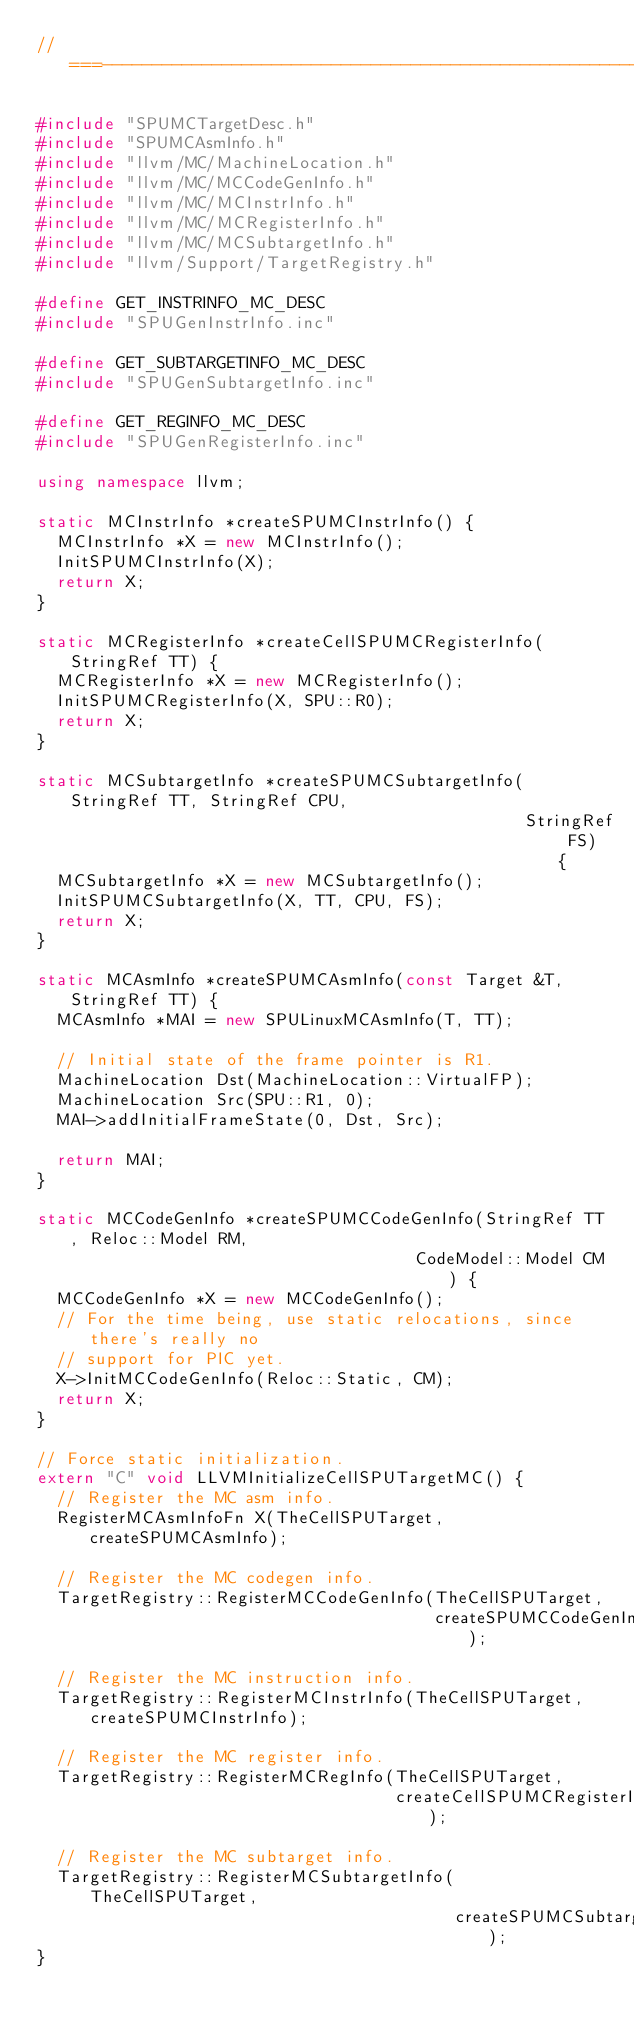<code> <loc_0><loc_0><loc_500><loc_500><_C++_>//===----------------------------------------------------------------------===//

#include "SPUMCTargetDesc.h"
#include "SPUMCAsmInfo.h"
#include "llvm/MC/MachineLocation.h"
#include "llvm/MC/MCCodeGenInfo.h"
#include "llvm/MC/MCInstrInfo.h"
#include "llvm/MC/MCRegisterInfo.h"
#include "llvm/MC/MCSubtargetInfo.h"
#include "llvm/Support/TargetRegistry.h"

#define GET_INSTRINFO_MC_DESC
#include "SPUGenInstrInfo.inc"

#define GET_SUBTARGETINFO_MC_DESC
#include "SPUGenSubtargetInfo.inc"

#define GET_REGINFO_MC_DESC
#include "SPUGenRegisterInfo.inc"

using namespace llvm;

static MCInstrInfo *createSPUMCInstrInfo() {
  MCInstrInfo *X = new MCInstrInfo();
  InitSPUMCInstrInfo(X);
  return X;
}

static MCRegisterInfo *createCellSPUMCRegisterInfo(StringRef TT) {
  MCRegisterInfo *X = new MCRegisterInfo();
  InitSPUMCRegisterInfo(X, SPU::R0);
  return X;
}

static MCSubtargetInfo *createSPUMCSubtargetInfo(StringRef TT, StringRef CPU,
                                                 StringRef FS) {
  MCSubtargetInfo *X = new MCSubtargetInfo();
  InitSPUMCSubtargetInfo(X, TT, CPU, FS);
  return X;
}

static MCAsmInfo *createSPUMCAsmInfo(const Target &T, StringRef TT) {
  MCAsmInfo *MAI = new SPULinuxMCAsmInfo(T, TT);

  // Initial state of the frame pointer is R1.
  MachineLocation Dst(MachineLocation::VirtualFP);
  MachineLocation Src(SPU::R1, 0);
  MAI->addInitialFrameState(0, Dst, Src);

  return MAI;
}

static MCCodeGenInfo *createSPUMCCodeGenInfo(StringRef TT, Reloc::Model RM,
                                      CodeModel::Model CM) {
  MCCodeGenInfo *X = new MCCodeGenInfo();
  // For the time being, use static relocations, since there's really no
  // support for PIC yet.
  X->InitMCCodeGenInfo(Reloc::Static, CM);
  return X;
}

// Force static initialization.
extern "C" void LLVMInitializeCellSPUTargetMC() {
  // Register the MC asm info.
  RegisterMCAsmInfoFn X(TheCellSPUTarget, createSPUMCAsmInfo);

  // Register the MC codegen info.
  TargetRegistry::RegisterMCCodeGenInfo(TheCellSPUTarget,
                                        createSPUMCCodeGenInfo);

  // Register the MC instruction info.
  TargetRegistry::RegisterMCInstrInfo(TheCellSPUTarget, createSPUMCInstrInfo);

  // Register the MC register info.
  TargetRegistry::RegisterMCRegInfo(TheCellSPUTarget,
                                    createCellSPUMCRegisterInfo);

  // Register the MC subtarget info.
  TargetRegistry::RegisterMCSubtargetInfo(TheCellSPUTarget,
                                          createSPUMCSubtargetInfo);
}
</code> 